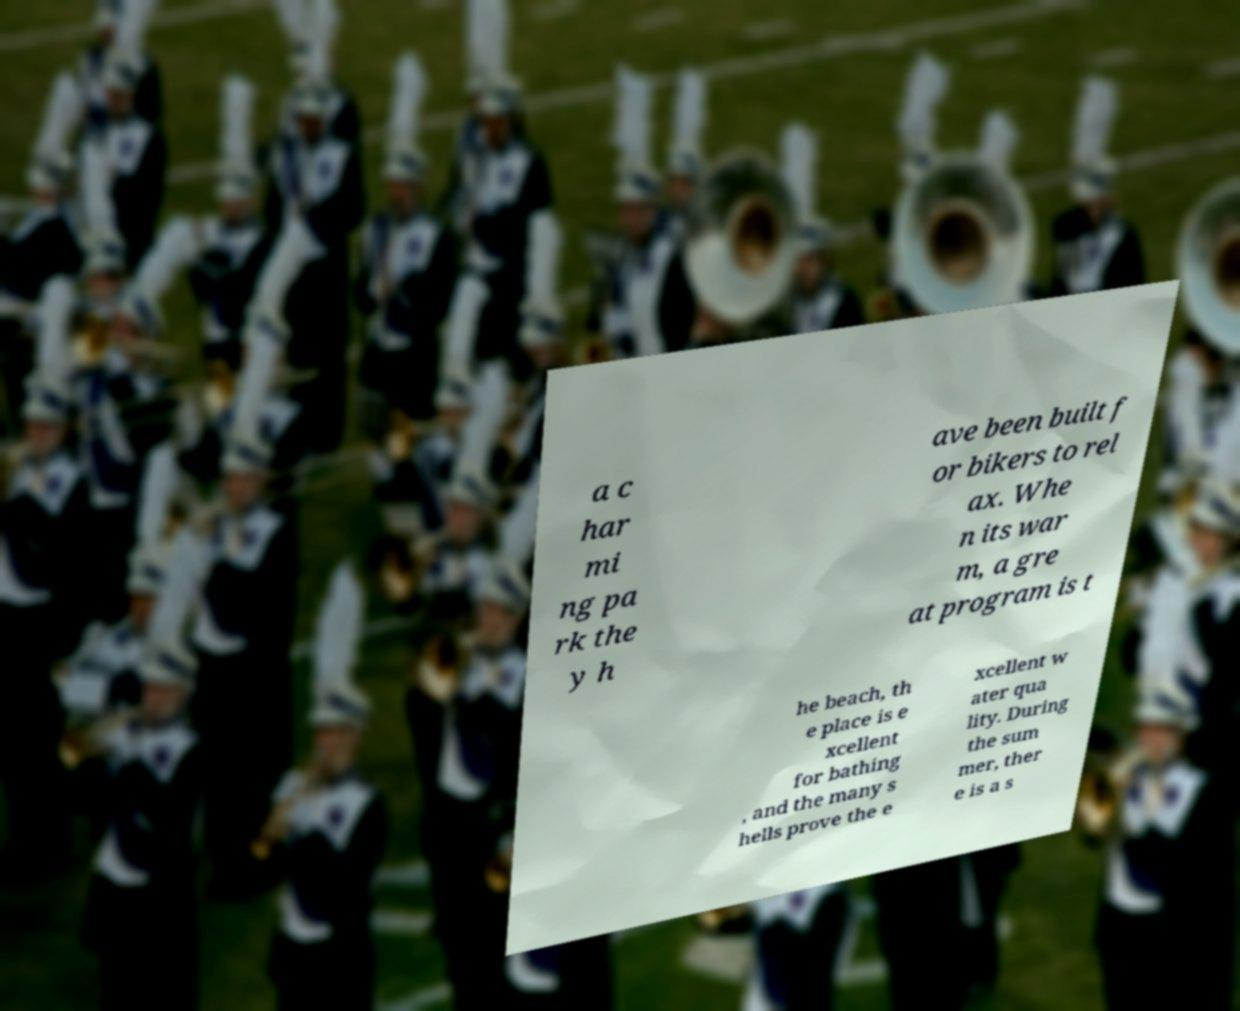Can you accurately transcribe the text from the provided image for me? a c har mi ng pa rk the y h ave been built f or bikers to rel ax. Whe n its war m, a gre at program is t he beach, th e place is e xcellent for bathing , and the many s hells prove the e xcellent w ater qua lity. During the sum mer, ther e is a s 